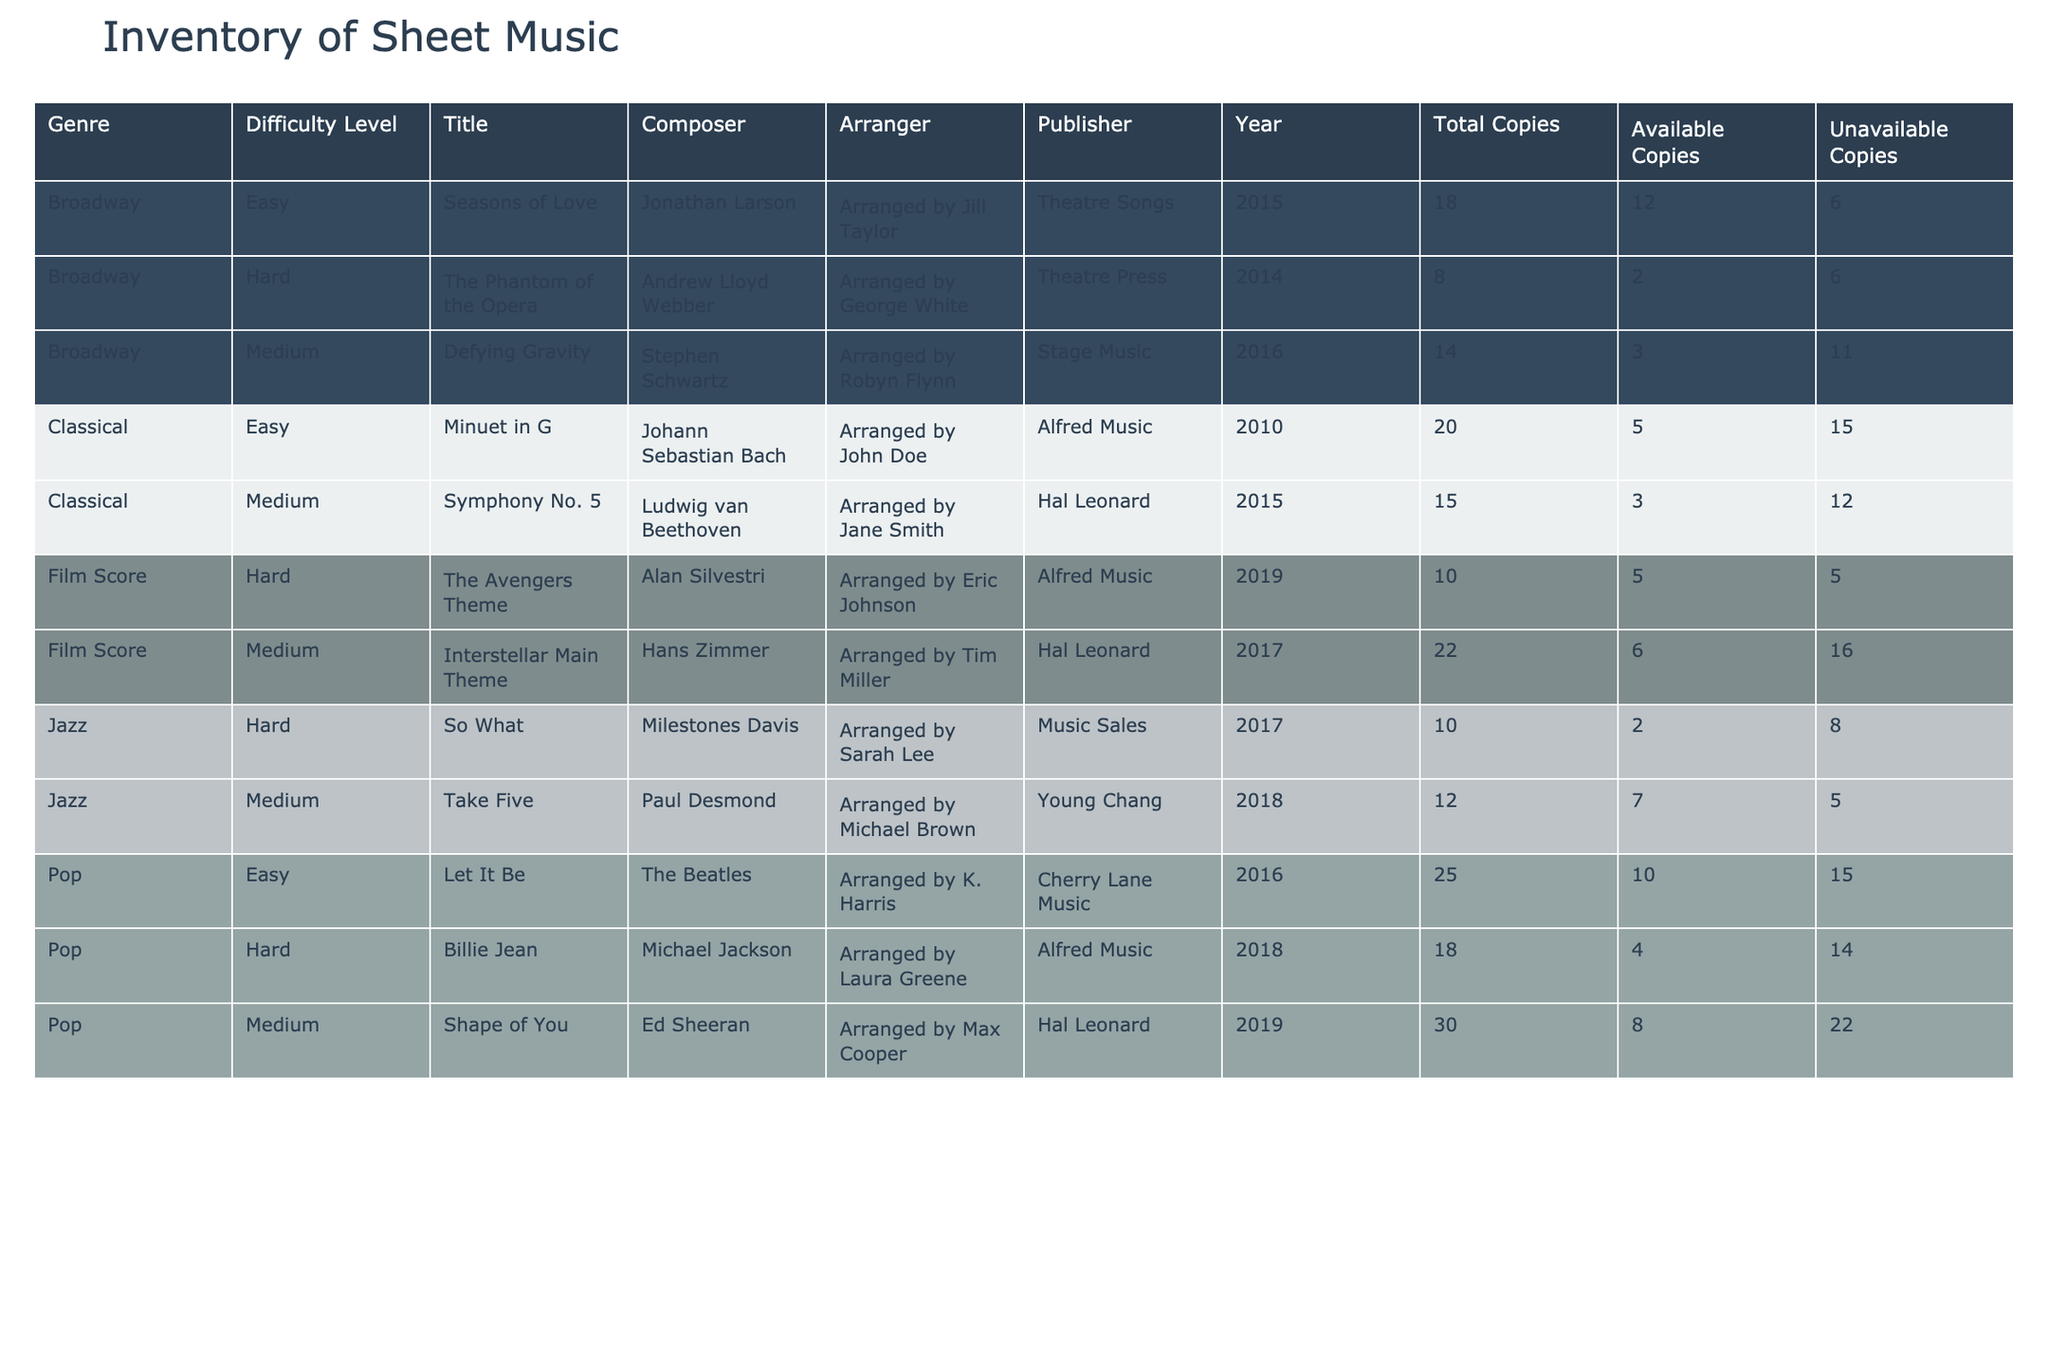What is the total number of available copies for Jazz sheet music? There are two types of Jazz sheet music listed in the table. The available copies for "Take Five" is 7 and for "So What" is 2. Adding these together gives 7 + 2 = 9.
Answer: 9 How many Classical pieces have a difficulty level of Hard? None of the Classical pieces listed in the table have a difficulty level marked as Hard. Therefore, the count is zero.
Answer: 0 Which genre has the most available copies of sheet music? First, I identify the total available copies for each genre: Classical (5 + 3 = 8), Jazz (7 + 2 = 9), Pop (10 + 8 + 4 = 22), Film Score (6 + 5 = 11), and Broadway (12 + 3 + 2 = 17). Pop has the highest with 22 available copies.
Answer: Pop Is there any Film Score sheet music that is categorized as Easy? The table does not list any Film Score sheet music with an Easy difficulty level. Based on the data, the answer is no.
Answer: No What is the average number of available copies for Broadway sheet music? The available copies for Broadway are 12, 3, and 2. I sum these parts: 12 + 3 + 2 = 17. There are 3 Broadway pieces, thus the average is 17/3 = approximately 5.67.
Answer: 5.67 How many copies of Pop sheet music are unavailable? There are three Pop pieces with the following totals: 25, 30, and 18 copies. Subtracting the available copies (10, 8, and 4) gives unavailable copies of 25 - 10 = 15, 30 - 8 = 22, and 18 - 4 = 14. Adding these unavailable copies gives 15 + 22 + 14 = 51.
Answer: 51 What is the total number of copies for all sheet music categorized as Hard? First, I identify the total copies for Hard pieces: "So What" has 10, "Billie Jean" has 18, "The Avengers Theme" has 10, and "The Phantom of the Opera" has 8. Adding these together gives 10 + 18 + 10 + 8 = 56 copies in total for Hard categories.
Answer: 56 Is there any Pop sheet music arranged by Alfred Music? Only "Billie Jean" is arranged by Alfred Music in the Pop category according to the table. Therefore, the answer is yes.
Answer: Yes Which composer has the least number of available copies in the table? "So What" by Miles Davis has 2 available copies, which is the lowest number across all entries listed. Therefore, the answer is Miles Davis.
Answer: Miles Davis 